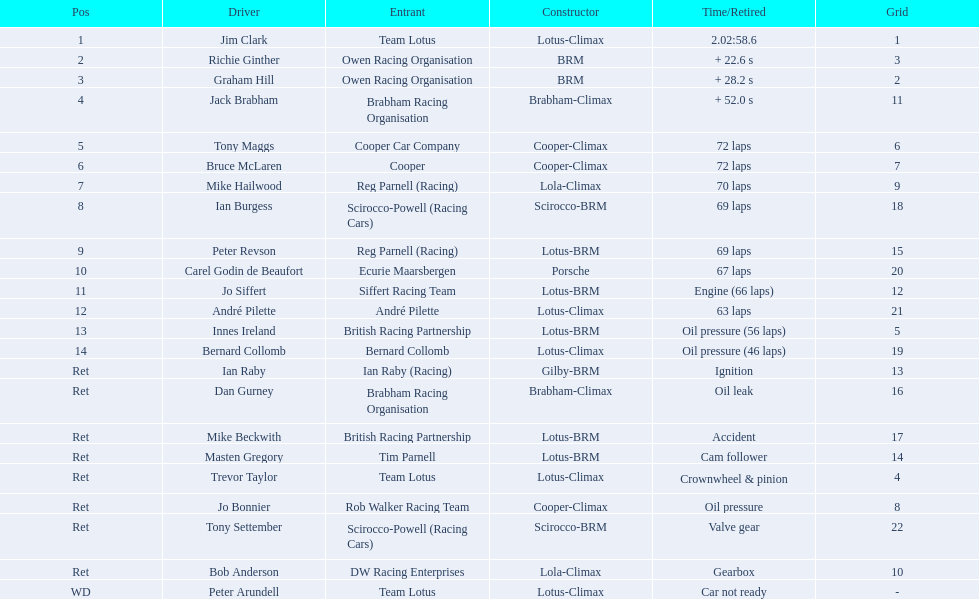Who were the drivers at the 1963 international gold cup? Jim Clark, Richie Ginther, Graham Hill, Jack Brabham, Tony Maggs, Bruce McLaren, Mike Hailwood, Ian Burgess, Peter Revson, Carel Godin de Beaufort, Jo Siffert, André Pilette, Innes Ireland, Bernard Collomb, Ian Raby, Dan Gurney, Mike Beckwith, Masten Gregory, Trevor Taylor, Jo Bonnier, Tony Settember, Bob Anderson, Peter Arundell. Would you be able to parse every entry in this table? {'header': ['Pos', 'Driver', 'Entrant', 'Constructor', 'Time/Retired', 'Grid'], 'rows': [['1', 'Jim Clark', 'Team Lotus', 'Lotus-Climax', '2.02:58.6', '1'], ['2', 'Richie Ginther', 'Owen Racing Organisation', 'BRM', '+ 22.6 s', '3'], ['3', 'Graham Hill', 'Owen Racing Organisation', 'BRM', '+ 28.2 s', '2'], ['4', 'Jack Brabham', 'Brabham Racing Organisation', 'Brabham-Climax', '+ 52.0 s', '11'], ['5', 'Tony Maggs', 'Cooper Car Company', 'Cooper-Climax', '72 laps', '6'], ['6', 'Bruce McLaren', 'Cooper', 'Cooper-Climax', '72 laps', '7'], ['7', 'Mike Hailwood', 'Reg Parnell (Racing)', 'Lola-Climax', '70 laps', '9'], ['8', 'Ian Burgess', 'Scirocco-Powell (Racing Cars)', 'Scirocco-BRM', '69 laps', '18'], ['9', 'Peter Revson', 'Reg Parnell (Racing)', 'Lotus-BRM', '69 laps', '15'], ['10', 'Carel Godin de Beaufort', 'Ecurie Maarsbergen', 'Porsche', '67 laps', '20'], ['11', 'Jo Siffert', 'Siffert Racing Team', 'Lotus-BRM', 'Engine (66 laps)', '12'], ['12', 'André Pilette', 'André Pilette', 'Lotus-Climax', '63 laps', '21'], ['13', 'Innes Ireland', 'British Racing Partnership', 'Lotus-BRM', 'Oil pressure (56 laps)', '5'], ['14', 'Bernard Collomb', 'Bernard Collomb', 'Lotus-Climax', 'Oil pressure (46 laps)', '19'], ['Ret', 'Ian Raby', 'Ian Raby (Racing)', 'Gilby-BRM', 'Ignition', '13'], ['Ret', 'Dan Gurney', 'Brabham Racing Organisation', 'Brabham-Climax', 'Oil leak', '16'], ['Ret', 'Mike Beckwith', 'British Racing Partnership', 'Lotus-BRM', 'Accident', '17'], ['Ret', 'Masten Gregory', 'Tim Parnell', 'Lotus-BRM', 'Cam follower', '14'], ['Ret', 'Trevor Taylor', 'Team Lotus', 'Lotus-Climax', 'Crownwheel & pinion', '4'], ['Ret', 'Jo Bonnier', 'Rob Walker Racing Team', 'Cooper-Climax', 'Oil pressure', '8'], ['Ret', 'Tony Settember', 'Scirocco-Powell (Racing Cars)', 'Scirocco-BRM', 'Valve gear', '22'], ['Ret', 'Bob Anderson', 'DW Racing Enterprises', 'Lola-Climax', 'Gearbox', '10'], ['WD', 'Peter Arundell', 'Team Lotus', 'Lotus-Climax', 'Car not ready', '-']]} What was tony maggs position? 5. What was jo siffert? 11. Who came in earlier? Tony Maggs. 